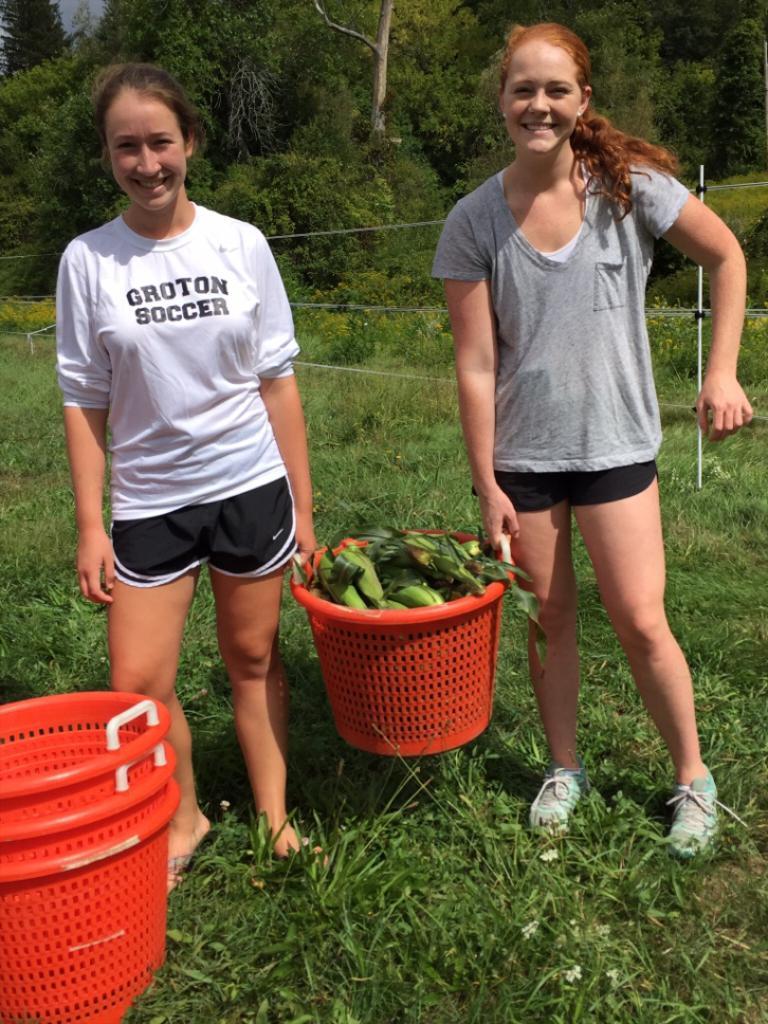What kind of soccer?
Provide a short and direct response. Groton. What sport does she play?
Ensure brevity in your answer.  Soccer. 